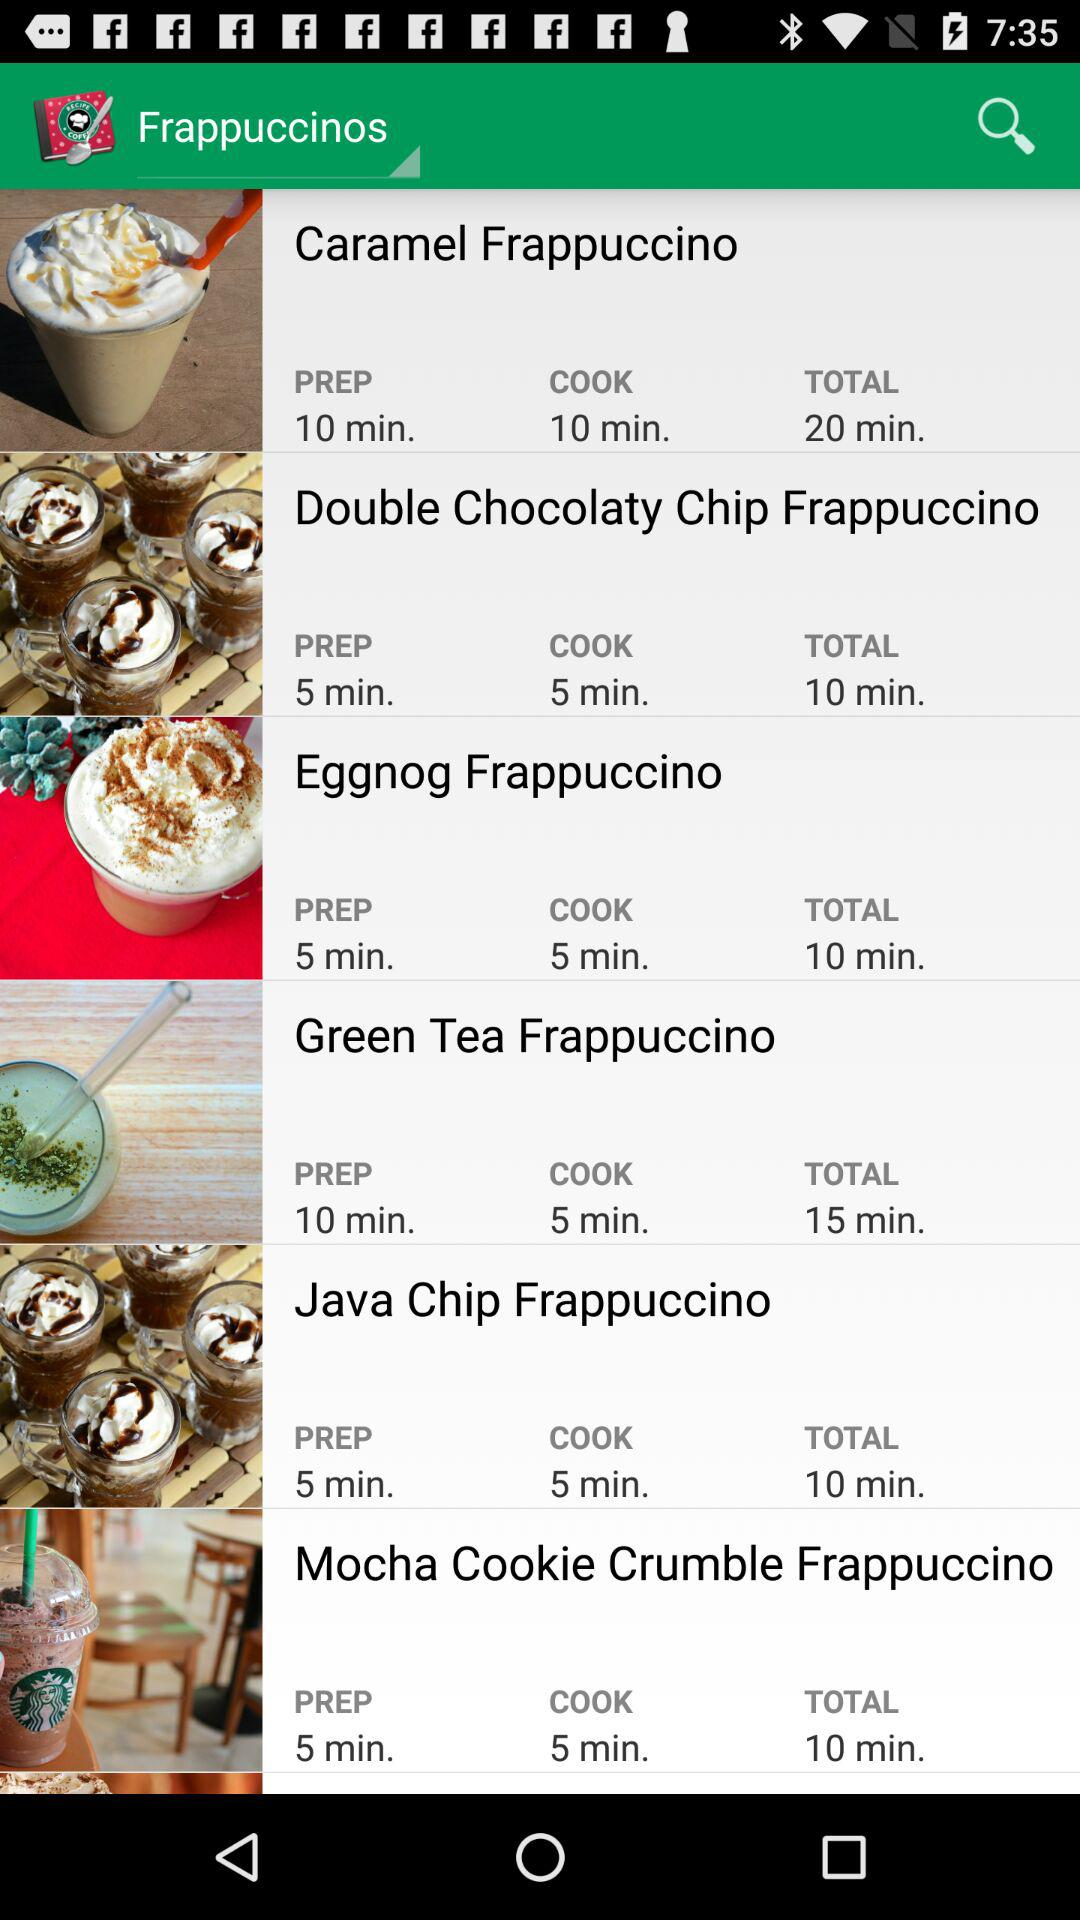What is the preparation time for a "Green Tea Frappuccino"? The preparation time for a "Green Tea Frappuccino" is 10 minutes. 